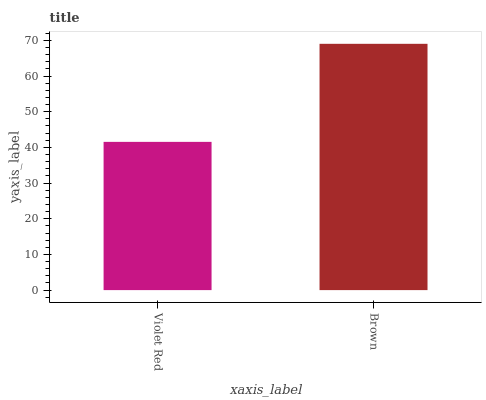Is Brown the minimum?
Answer yes or no. No. Is Brown greater than Violet Red?
Answer yes or no. Yes. Is Violet Red less than Brown?
Answer yes or no. Yes. Is Violet Red greater than Brown?
Answer yes or no. No. Is Brown less than Violet Red?
Answer yes or no. No. Is Brown the high median?
Answer yes or no. Yes. Is Violet Red the low median?
Answer yes or no. Yes. Is Violet Red the high median?
Answer yes or no. No. Is Brown the low median?
Answer yes or no. No. 